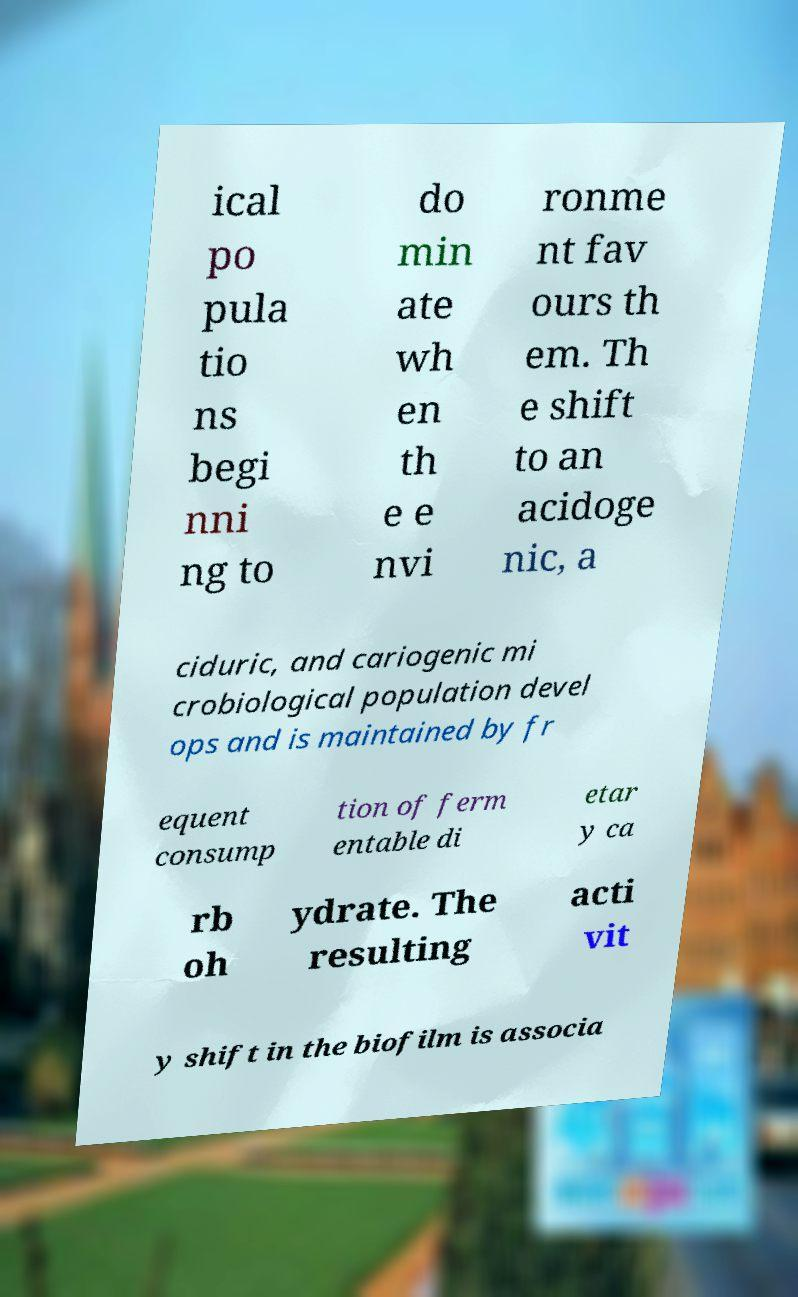There's text embedded in this image that I need extracted. Can you transcribe it verbatim? ical po pula tio ns begi nni ng to do min ate wh en th e e nvi ronme nt fav ours th em. Th e shift to an acidoge nic, a ciduric, and cariogenic mi crobiological population devel ops and is maintained by fr equent consump tion of ferm entable di etar y ca rb oh ydrate. The resulting acti vit y shift in the biofilm is associa 